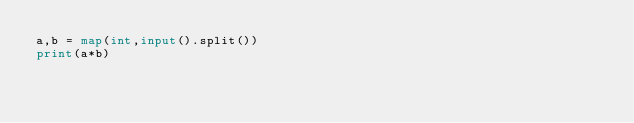Convert code to text. <code><loc_0><loc_0><loc_500><loc_500><_Python_>a,b = map(int,input().split())
print(a*b)</code> 